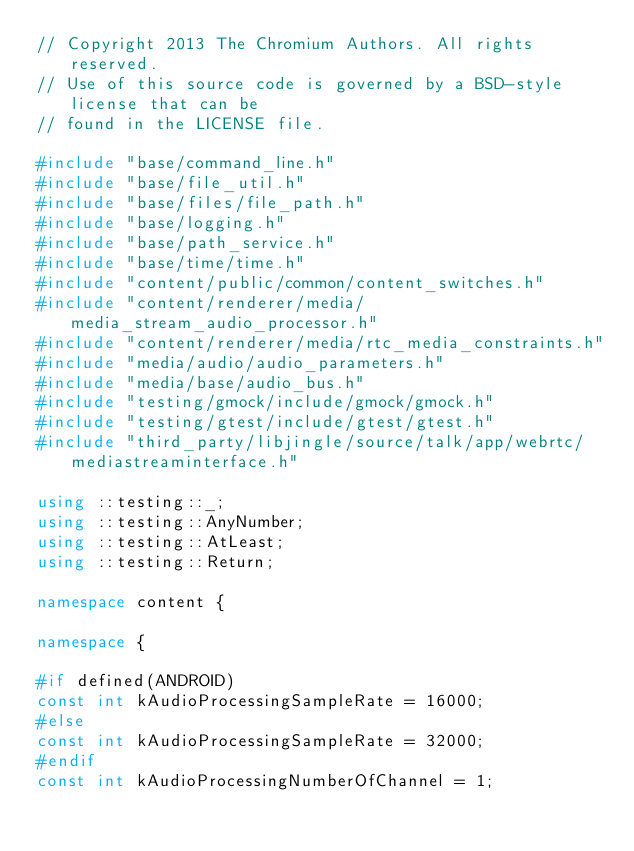<code> <loc_0><loc_0><loc_500><loc_500><_C++_>// Copyright 2013 The Chromium Authors. All rights reserved.
// Use of this source code is governed by a BSD-style license that can be
// found in the LICENSE file.

#include "base/command_line.h"
#include "base/file_util.h"
#include "base/files/file_path.h"
#include "base/logging.h"
#include "base/path_service.h"
#include "base/time/time.h"
#include "content/public/common/content_switches.h"
#include "content/renderer/media/media_stream_audio_processor.h"
#include "content/renderer/media/rtc_media_constraints.h"
#include "media/audio/audio_parameters.h"
#include "media/base/audio_bus.h"
#include "testing/gmock/include/gmock/gmock.h"
#include "testing/gtest/include/gtest/gtest.h"
#include "third_party/libjingle/source/talk/app/webrtc/mediastreaminterface.h"

using ::testing::_;
using ::testing::AnyNumber;
using ::testing::AtLeast;
using ::testing::Return;

namespace content {

namespace {

#if defined(ANDROID)
const int kAudioProcessingSampleRate = 16000;
#else
const int kAudioProcessingSampleRate = 32000;
#endif
const int kAudioProcessingNumberOfChannel = 1;
</code> 